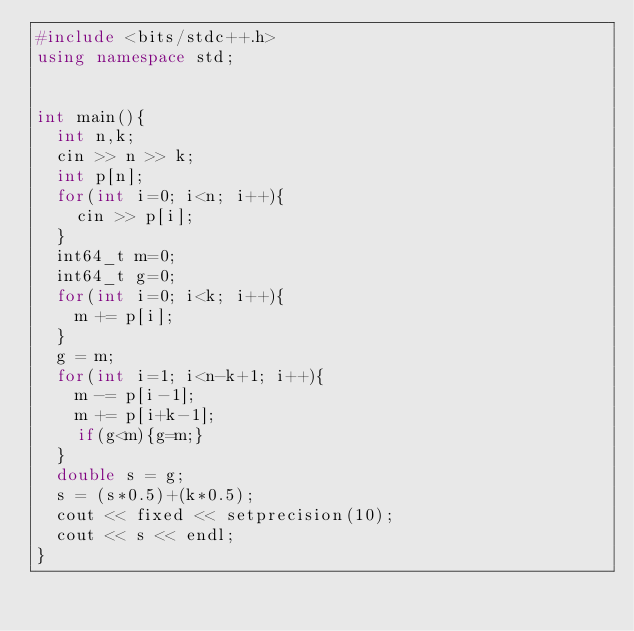Convert code to text. <code><loc_0><loc_0><loc_500><loc_500><_C++_>#include <bits/stdc++.h>
using namespace std;


int main(){
  int n,k;
  cin >> n >> k;
  int p[n];
  for(int i=0; i<n; i++){
    cin >> p[i];
  }
  int64_t m=0;
  int64_t g=0;
  for(int i=0; i<k; i++){
    m += p[i];
  }
  g = m;
  for(int i=1; i<n-k+1; i++){
    m -= p[i-1];
    m += p[i+k-1];
    if(g<m){g=m;}
  }
  double s = g;
  s = (s*0.5)+(k*0.5);
  cout << fixed << setprecision(10);
  cout << s << endl;
}</code> 